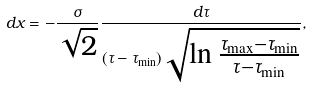<formula> <loc_0><loc_0><loc_500><loc_500>d x = - \frac { \sigma } { \sqrt { 2 } } \frac { d \tau } { ( \tau - \tau _ { \min } ) \sqrt { \ln \frac { \tau _ { \max } - \tau _ { \min } } { \tau - \tau _ { \min } } } } ,</formula> 